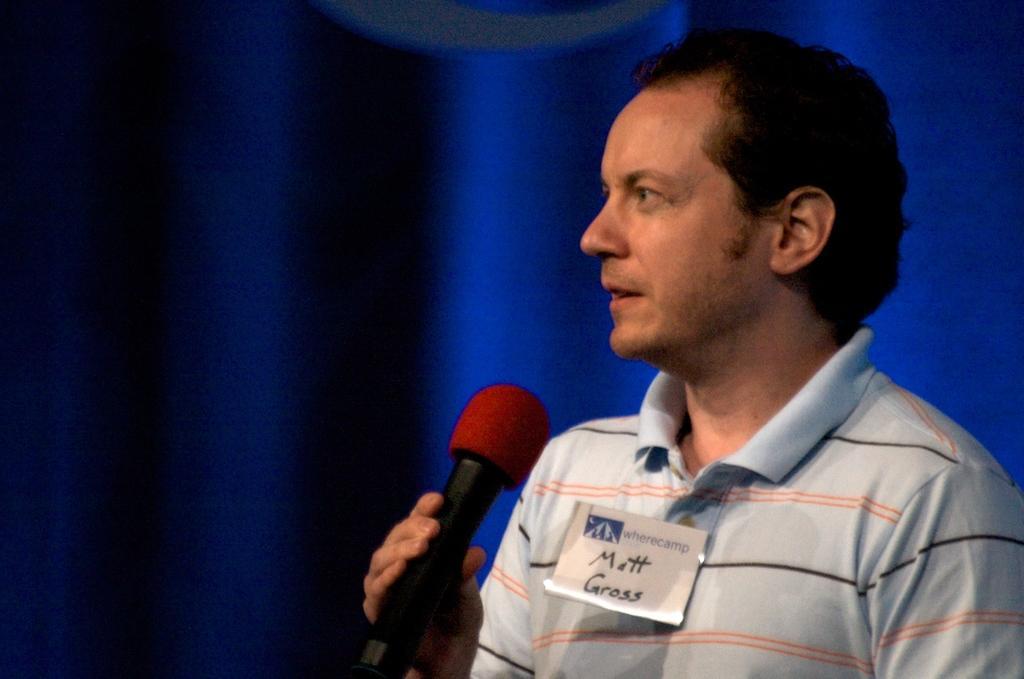Can you describe this image briefly? In the image we can see there is a man who is standing and holding mic in his hand. 